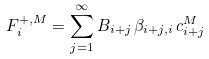Convert formula to latex. <formula><loc_0><loc_0><loc_500><loc_500>F _ { i } ^ { + , M } = \sum _ { j = 1 } ^ { \infty } B _ { i + j } \, \beta _ { i + j , i } \, c ^ { M } _ { i + j }</formula> 